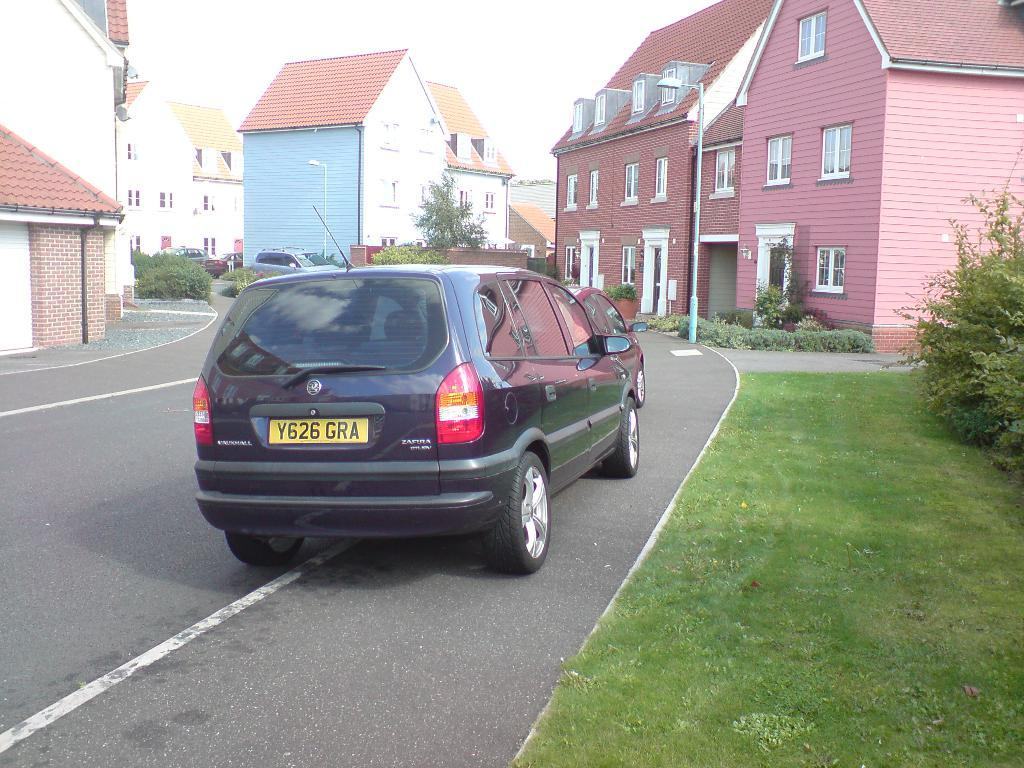<image>
Offer a succinct explanation of the picture presented. a car that has GRA written on the back 